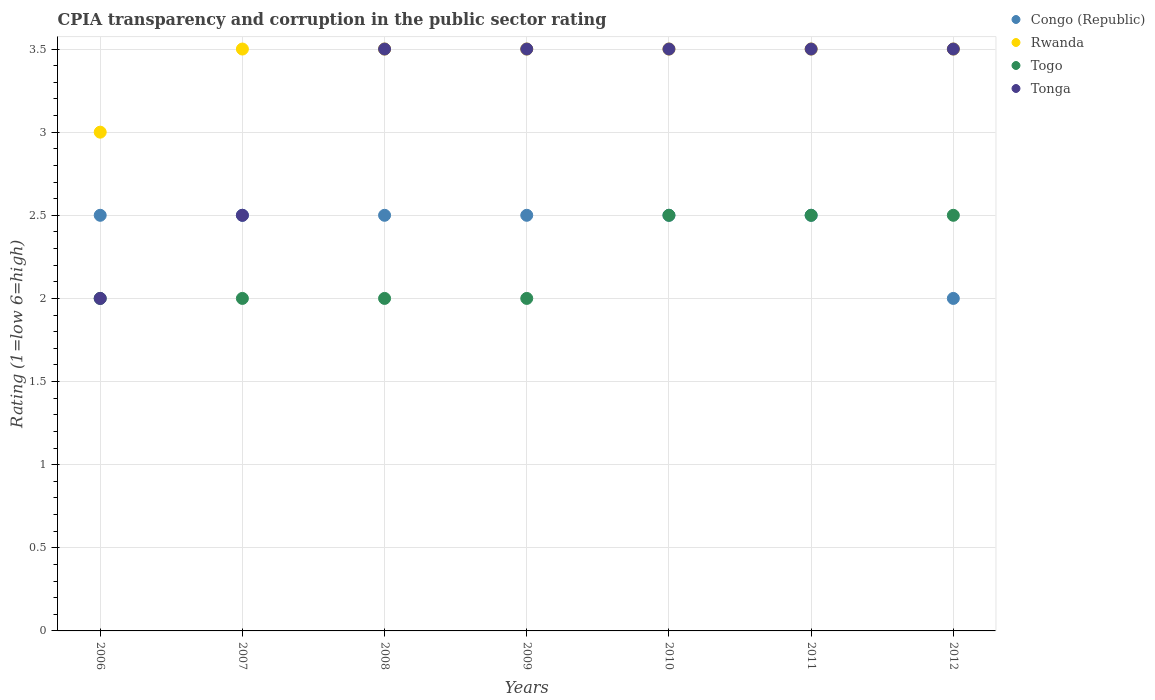How many different coloured dotlines are there?
Ensure brevity in your answer.  4. Across all years, what is the maximum CPIA rating in Congo (Republic)?
Your answer should be very brief. 2.5. Across all years, what is the minimum CPIA rating in Congo (Republic)?
Offer a terse response. 2. In which year was the CPIA rating in Tonga maximum?
Your answer should be very brief. 2008. What is the total CPIA rating in Tonga in the graph?
Your answer should be compact. 22. What is the difference between the CPIA rating in Togo in 2006 and that in 2010?
Your answer should be very brief. -0.5. What is the average CPIA rating in Congo (Republic) per year?
Make the answer very short. 2.43. In the year 2010, what is the difference between the CPIA rating in Rwanda and CPIA rating in Togo?
Offer a very short reply. 1. What is the ratio of the CPIA rating in Tonga in 2006 to that in 2008?
Your answer should be compact. 0.57. What is the difference between the highest and the lowest CPIA rating in Tonga?
Give a very brief answer. 1.5. In how many years, is the CPIA rating in Togo greater than the average CPIA rating in Togo taken over all years?
Offer a terse response. 3. Is the sum of the CPIA rating in Togo in 2007 and 2012 greater than the maximum CPIA rating in Congo (Republic) across all years?
Make the answer very short. Yes. Is it the case that in every year, the sum of the CPIA rating in Congo (Republic) and CPIA rating in Rwanda  is greater than the sum of CPIA rating in Tonga and CPIA rating in Togo?
Provide a succinct answer. Yes. Is it the case that in every year, the sum of the CPIA rating in Congo (Republic) and CPIA rating in Tonga  is greater than the CPIA rating in Rwanda?
Give a very brief answer. Yes. Does the CPIA rating in Togo monotonically increase over the years?
Your response must be concise. No. Is the CPIA rating in Tonga strictly greater than the CPIA rating in Rwanda over the years?
Your response must be concise. No. How many dotlines are there?
Make the answer very short. 4. Does the graph contain grids?
Your answer should be compact. Yes. How many legend labels are there?
Provide a short and direct response. 4. What is the title of the graph?
Your answer should be compact. CPIA transparency and corruption in the public sector rating. What is the label or title of the X-axis?
Ensure brevity in your answer.  Years. What is the Rating (1=low 6=high) of Congo (Republic) in 2006?
Make the answer very short. 2.5. What is the Rating (1=low 6=high) in Tonga in 2006?
Make the answer very short. 2. What is the Rating (1=low 6=high) of Congo (Republic) in 2007?
Make the answer very short. 2.5. What is the Rating (1=low 6=high) in Togo in 2007?
Provide a succinct answer. 2. What is the Rating (1=low 6=high) in Tonga in 2007?
Your response must be concise. 2.5. What is the Rating (1=low 6=high) in Rwanda in 2008?
Offer a terse response. 3.5. What is the Rating (1=low 6=high) in Togo in 2008?
Ensure brevity in your answer.  2. What is the Rating (1=low 6=high) of Togo in 2009?
Your answer should be very brief. 2. What is the Rating (1=low 6=high) in Congo (Republic) in 2010?
Give a very brief answer. 2.5. What is the Rating (1=low 6=high) of Togo in 2010?
Provide a succinct answer. 2.5. What is the Rating (1=low 6=high) in Tonga in 2010?
Your response must be concise. 3.5. What is the Rating (1=low 6=high) of Congo (Republic) in 2011?
Give a very brief answer. 2.5. What is the Rating (1=low 6=high) in Rwanda in 2011?
Give a very brief answer. 3.5. What is the Rating (1=low 6=high) in Congo (Republic) in 2012?
Make the answer very short. 2. What is the Rating (1=low 6=high) in Togo in 2012?
Make the answer very short. 2.5. What is the Rating (1=low 6=high) of Tonga in 2012?
Make the answer very short. 3.5. Across all years, what is the maximum Rating (1=low 6=high) in Tonga?
Ensure brevity in your answer.  3.5. Across all years, what is the minimum Rating (1=low 6=high) in Congo (Republic)?
Keep it short and to the point. 2. Across all years, what is the minimum Rating (1=low 6=high) in Tonga?
Keep it short and to the point. 2. What is the total Rating (1=low 6=high) of Rwanda in the graph?
Ensure brevity in your answer.  24. What is the total Rating (1=low 6=high) in Tonga in the graph?
Make the answer very short. 22. What is the difference between the Rating (1=low 6=high) in Congo (Republic) in 2006 and that in 2007?
Provide a short and direct response. 0. What is the difference between the Rating (1=low 6=high) of Togo in 2006 and that in 2007?
Provide a short and direct response. 0. What is the difference between the Rating (1=low 6=high) of Tonga in 2006 and that in 2007?
Make the answer very short. -0.5. What is the difference between the Rating (1=low 6=high) in Togo in 2006 and that in 2008?
Ensure brevity in your answer.  0. What is the difference between the Rating (1=low 6=high) of Togo in 2006 and that in 2009?
Offer a terse response. 0. What is the difference between the Rating (1=low 6=high) of Tonga in 2006 and that in 2009?
Provide a succinct answer. -1.5. What is the difference between the Rating (1=low 6=high) of Rwanda in 2006 and that in 2010?
Provide a short and direct response. -0.5. What is the difference between the Rating (1=low 6=high) in Togo in 2006 and that in 2010?
Your response must be concise. -0.5. What is the difference between the Rating (1=low 6=high) of Tonga in 2006 and that in 2010?
Offer a very short reply. -1.5. What is the difference between the Rating (1=low 6=high) of Congo (Republic) in 2006 and that in 2011?
Ensure brevity in your answer.  0. What is the difference between the Rating (1=low 6=high) of Togo in 2006 and that in 2011?
Your answer should be very brief. -0.5. What is the difference between the Rating (1=low 6=high) of Tonga in 2006 and that in 2011?
Offer a terse response. -1.5. What is the difference between the Rating (1=low 6=high) in Tonga in 2006 and that in 2012?
Your response must be concise. -1.5. What is the difference between the Rating (1=low 6=high) in Tonga in 2007 and that in 2008?
Your answer should be compact. -1. What is the difference between the Rating (1=low 6=high) in Congo (Republic) in 2007 and that in 2010?
Your answer should be compact. 0. What is the difference between the Rating (1=low 6=high) in Rwanda in 2007 and that in 2010?
Provide a short and direct response. 0. What is the difference between the Rating (1=low 6=high) in Togo in 2007 and that in 2010?
Offer a very short reply. -0.5. What is the difference between the Rating (1=low 6=high) of Togo in 2007 and that in 2011?
Provide a short and direct response. -0.5. What is the difference between the Rating (1=low 6=high) in Rwanda in 2007 and that in 2012?
Make the answer very short. 0. What is the difference between the Rating (1=low 6=high) in Togo in 2007 and that in 2012?
Your answer should be compact. -0.5. What is the difference between the Rating (1=low 6=high) in Togo in 2008 and that in 2009?
Your response must be concise. 0. What is the difference between the Rating (1=low 6=high) in Congo (Republic) in 2008 and that in 2010?
Your answer should be very brief. 0. What is the difference between the Rating (1=low 6=high) of Rwanda in 2008 and that in 2010?
Your response must be concise. 0. What is the difference between the Rating (1=low 6=high) in Tonga in 2008 and that in 2010?
Offer a terse response. 0. What is the difference between the Rating (1=low 6=high) in Rwanda in 2008 and that in 2011?
Provide a short and direct response. 0. What is the difference between the Rating (1=low 6=high) of Togo in 2008 and that in 2012?
Your response must be concise. -0.5. What is the difference between the Rating (1=low 6=high) in Tonga in 2008 and that in 2012?
Give a very brief answer. 0. What is the difference between the Rating (1=low 6=high) of Togo in 2009 and that in 2010?
Provide a short and direct response. -0.5. What is the difference between the Rating (1=low 6=high) in Tonga in 2009 and that in 2010?
Keep it short and to the point. 0. What is the difference between the Rating (1=low 6=high) of Togo in 2009 and that in 2011?
Offer a terse response. -0.5. What is the difference between the Rating (1=low 6=high) of Congo (Republic) in 2009 and that in 2012?
Offer a very short reply. 0.5. What is the difference between the Rating (1=low 6=high) of Rwanda in 2009 and that in 2012?
Provide a short and direct response. 0. What is the difference between the Rating (1=low 6=high) in Tonga in 2009 and that in 2012?
Provide a succinct answer. 0. What is the difference between the Rating (1=low 6=high) in Congo (Republic) in 2010 and that in 2011?
Give a very brief answer. 0. What is the difference between the Rating (1=low 6=high) in Rwanda in 2010 and that in 2011?
Make the answer very short. 0. What is the difference between the Rating (1=low 6=high) in Tonga in 2010 and that in 2011?
Keep it short and to the point. 0. What is the difference between the Rating (1=low 6=high) of Congo (Republic) in 2010 and that in 2012?
Your response must be concise. 0.5. What is the difference between the Rating (1=low 6=high) in Togo in 2010 and that in 2012?
Provide a short and direct response. 0. What is the difference between the Rating (1=low 6=high) in Tonga in 2010 and that in 2012?
Offer a very short reply. 0. What is the difference between the Rating (1=low 6=high) of Togo in 2011 and that in 2012?
Your response must be concise. 0. What is the difference between the Rating (1=low 6=high) in Congo (Republic) in 2006 and the Rating (1=low 6=high) in Rwanda in 2007?
Offer a terse response. -1. What is the difference between the Rating (1=low 6=high) in Rwanda in 2006 and the Rating (1=low 6=high) in Togo in 2007?
Make the answer very short. 1. What is the difference between the Rating (1=low 6=high) of Togo in 2006 and the Rating (1=low 6=high) of Tonga in 2007?
Offer a very short reply. -0.5. What is the difference between the Rating (1=low 6=high) in Congo (Republic) in 2006 and the Rating (1=low 6=high) in Rwanda in 2008?
Your response must be concise. -1. What is the difference between the Rating (1=low 6=high) of Rwanda in 2006 and the Rating (1=low 6=high) of Togo in 2008?
Your answer should be very brief. 1. What is the difference between the Rating (1=low 6=high) in Rwanda in 2006 and the Rating (1=low 6=high) in Tonga in 2008?
Give a very brief answer. -0.5. What is the difference between the Rating (1=low 6=high) of Congo (Republic) in 2006 and the Rating (1=low 6=high) of Togo in 2009?
Offer a terse response. 0.5. What is the difference between the Rating (1=low 6=high) of Congo (Republic) in 2006 and the Rating (1=low 6=high) of Tonga in 2009?
Your response must be concise. -1. What is the difference between the Rating (1=low 6=high) in Rwanda in 2006 and the Rating (1=low 6=high) in Togo in 2009?
Provide a short and direct response. 1. What is the difference between the Rating (1=low 6=high) in Rwanda in 2006 and the Rating (1=low 6=high) in Tonga in 2009?
Your answer should be very brief. -0.5. What is the difference between the Rating (1=low 6=high) in Togo in 2006 and the Rating (1=low 6=high) in Tonga in 2009?
Offer a terse response. -1.5. What is the difference between the Rating (1=low 6=high) of Congo (Republic) in 2006 and the Rating (1=low 6=high) of Rwanda in 2010?
Provide a short and direct response. -1. What is the difference between the Rating (1=low 6=high) of Congo (Republic) in 2006 and the Rating (1=low 6=high) of Togo in 2010?
Offer a very short reply. 0. What is the difference between the Rating (1=low 6=high) of Congo (Republic) in 2006 and the Rating (1=low 6=high) of Tonga in 2010?
Make the answer very short. -1. What is the difference between the Rating (1=low 6=high) in Rwanda in 2006 and the Rating (1=low 6=high) in Togo in 2010?
Make the answer very short. 0.5. What is the difference between the Rating (1=low 6=high) of Rwanda in 2006 and the Rating (1=low 6=high) of Tonga in 2010?
Offer a terse response. -0.5. What is the difference between the Rating (1=low 6=high) of Congo (Republic) in 2006 and the Rating (1=low 6=high) of Rwanda in 2011?
Your response must be concise. -1. What is the difference between the Rating (1=low 6=high) in Rwanda in 2006 and the Rating (1=low 6=high) in Togo in 2011?
Offer a very short reply. 0.5. What is the difference between the Rating (1=low 6=high) in Rwanda in 2006 and the Rating (1=low 6=high) in Tonga in 2011?
Keep it short and to the point. -0.5. What is the difference between the Rating (1=low 6=high) of Congo (Republic) in 2006 and the Rating (1=low 6=high) of Rwanda in 2012?
Keep it short and to the point. -1. What is the difference between the Rating (1=low 6=high) of Congo (Republic) in 2006 and the Rating (1=low 6=high) of Togo in 2012?
Your answer should be compact. 0. What is the difference between the Rating (1=low 6=high) in Congo (Republic) in 2006 and the Rating (1=low 6=high) in Tonga in 2012?
Ensure brevity in your answer.  -1. What is the difference between the Rating (1=low 6=high) of Togo in 2006 and the Rating (1=low 6=high) of Tonga in 2012?
Ensure brevity in your answer.  -1.5. What is the difference between the Rating (1=low 6=high) in Congo (Republic) in 2007 and the Rating (1=low 6=high) in Togo in 2008?
Keep it short and to the point. 0.5. What is the difference between the Rating (1=low 6=high) in Rwanda in 2007 and the Rating (1=low 6=high) in Tonga in 2008?
Offer a terse response. 0. What is the difference between the Rating (1=low 6=high) in Rwanda in 2007 and the Rating (1=low 6=high) in Togo in 2009?
Give a very brief answer. 1.5. What is the difference between the Rating (1=low 6=high) of Togo in 2007 and the Rating (1=low 6=high) of Tonga in 2009?
Ensure brevity in your answer.  -1.5. What is the difference between the Rating (1=low 6=high) of Rwanda in 2007 and the Rating (1=low 6=high) of Tonga in 2010?
Make the answer very short. 0. What is the difference between the Rating (1=low 6=high) in Togo in 2007 and the Rating (1=low 6=high) in Tonga in 2010?
Offer a very short reply. -1.5. What is the difference between the Rating (1=low 6=high) of Congo (Republic) in 2007 and the Rating (1=low 6=high) of Tonga in 2011?
Your answer should be compact. -1. What is the difference between the Rating (1=low 6=high) of Rwanda in 2007 and the Rating (1=low 6=high) of Tonga in 2011?
Make the answer very short. 0. What is the difference between the Rating (1=low 6=high) of Togo in 2007 and the Rating (1=low 6=high) of Tonga in 2011?
Ensure brevity in your answer.  -1.5. What is the difference between the Rating (1=low 6=high) of Togo in 2007 and the Rating (1=low 6=high) of Tonga in 2012?
Your answer should be very brief. -1.5. What is the difference between the Rating (1=low 6=high) in Congo (Republic) in 2008 and the Rating (1=low 6=high) in Togo in 2009?
Provide a short and direct response. 0.5. What is the difference between the Rating (1=low 6=high) in Congo (Republic) in 2008 and the Rating (1=low 6=high) in Tonga in 2009?
Your answer should be compact. -1. What is the difference between the Rating (1=low 6=high) of Togo in 2008 and the Rating (1=low 6=high) of Tonga in 2009?
Offer a very short reply. -1.5. What is the difference between the Rating (1=low 6=high) in Congo (Republic) in 2008 and the Rating (1=low 6=high) in Togo in 2010?
Provide a short and direct response. 0. What is the difference between the Rating (1=low 6=high) in Congo (Republic) in 2008 and the Rating (1=low 6=high) in Tonga in 2010?
Provide a short and direct response. -1. What is the difference between the Rating (1=low 6=high) in Congo (Republic) in 2008 and the Rating (1=low 6=high) in Rwanda in 2011?
Your response must be concise. -1. What is the difference between the Rating (1=low 6=high) of Togo in 2008 and the Rating (1=low 6=high) of Tonga in 2011?
Provide a succinct answer. -1.5. What is the difference between the Rating (1=low 6=high) of Congo (Republic) in 2008 and the Rating (1=low 6=high) of Tonga in 2012?
Make the answer very short. -1. What is the difference between the Rating (1=low 6=high) of Rwanda in 2008 and the Rating (1=low 6=high) of Togo in 2012?
Provide a short and direct response. 1. What is the difference between the Rating (1=low 6=high) of Rwanda in 2008 and the Rating (1=low 6=high) of Tonga in 2012?
Ensure brevity in your answer.  0. What is the difference between the Rating (1=low 6=high) of Congo (Republic) in 2009 and the Rating (1=low 6=high) of Togo in 2010?
Provide a succinct answer. 0. What is the difference between the Rating (1=low 6=high) of Congo (Republic) in 2009 and the Rating (1=low 6=high) of Togo in 2011?
Offer a terse response. 0. What is the difference between the Rating (1=low 6=high) in Togo in 2009 and the Rating (1=low 6=high) in Tonga in 2011?
Offer a very short reply. -1.5. What is the difference between the Rating (1=low 6=high) in Congo (Republic) in 2009 and the Rating (1=low 6=high) in Rwanda in 2012?
Offer a terse response. -1. What is the difference between the Rating (1=low 6=high) of Congo (Republic) in 2009 and the Rating (1=low 6=high) of Tonga in 2012?
Keep it short and to the point. -1. What is the difference between the Rating (1=low 6=high) in Rwanda in 2009 and the Rating (1=low 6=high) in Togo in 2012?
Ensure brevity in your answer.  1. What is the difference between the Rating (1=low 6=high) in Rwanda in 2009 and the Rating (1=low 6=high) in Tonga in 2012?
Provide a succinct answer. 0. What is the difference between the Rating (1=low 6=high) of Togo in 2009 and the Rating (1=low 6=high) of Tonga in 2012?
Make the answer very short. -1.5. What is the difference between the Rating (1=low 6=high) of Congo (Republic) in 2010 and the Rating (1=low 6=high) of Togo in 2011?
Make the answer very short. 0. What is the difference between the Rating (1=low 6=high) of Congo (Republic) in 2010 and the Rating (1=low 6=high) of Tonga in 2011?
Keep it short and to the point. -1. What is the difference between the Rating (1=low 6=high) of Rwanda in 2010 and the Rating (1=low 6=high) of Togo in 2011?
Offer a very short reply. 1. What is the difference between the Rating (1=low 6=high) in Congo (Republic) in 2010 and the Rating (1=low 6=high) in Togo in 2012?
Provide a succinct answer. 0. What is the difference between the Rating (1=low 6=high) in Rwanda in 2010 and the Rating (1=low 6=high) in Togo in 2012?
Your response must be concise. 1. What is the difference between the Rating (1=low 6=high) of Rwanda in 2010 and the Rating (1=low 6=high) of Tonga in 2012?
Your answer should be compact. 0. What is the difference between the Rating (1=low 6=high) of Congo (Republic) in 2011 and the Rating (1=low 6=high) of Rwanda in 2012?
Your answer should be very brief. -1. What is the difference between the Rating (1=low 6=high) in Congo (Republic) in 2011 and the Rating (1=low 6=high) in Togo in 2012?
Offer a terse response. 0. What is the difference between the Rating (1=low 6=high) in Rwanda in 2011 and the Rating (1=low 6=high) in Togo in 2012?
Provide a succinct answer. 1. What is the difference between the Rating (1=low 6=high) in Togo in 2011 and the Rating (1=low 6=high) in Tonga in 2012?
Your response must be concise. -1. What is the average Rating (1=low 6=high) of Congo (Republic) per year?
Your answer should be very brief. 2.43. What is the average Rating (1=low 6=high) in Rwanda per year?
Ensure brevity in your answer.  3.43. What is the average Rating (1=low 6=high) in Togo per year?
Keep it short and to the point. 2.21. What is the average Rating (1=low 6=high) in Tonga per year?
Your answer should be very brief. 3.14. In the year 2006, what is the difference between the Rating (1=low 6=high) of Congo (Republic) and Rating (1=low 6=high) of Tonga?
Your answer should be compact. 0.5. In the year 2006, what is the difference between the Rating (1=low 6=high) in Rwanda and Rating (1=low 6=high) in Tonga?
Offer a very short reply. 1. In the year 2006, what is the difference between the Rating (1=low 6=high) in Togo and Rating (1=low 6=high) in Tonga?
Offer a terse response. 0. In the year 2007, what is the difference between the Rating (1=low 6=high) of Congo (Republic) and Rating (1=low 6=high) of Rwanda?
Your response must be concise. -1. In the year 2007, what is the difference between the Rating (1=low 6=high) in Congo (Republic) and Rating (1=low 6=high) in Togo?
Your response must be concise. 0.5. In the year 2007, what is the difference between the Rating (1=low 6=high) in Congo (Republic) and Rating (1=low 6=high) in Tonga?
Make the answer very short. 0. In the year 2007, what is the difference between the Rating (1=low 6=high) in Rwanda and Rating (1=low 6=high) in Togo?
Your response must be concise. 1.5. In the year 2008, what is the difference between the Rating (1=low 6=high) in Congo (Republic) and Rating (1=low 6=high) in Tonga?
Your answer should be compact. -1. In the year 2008, what is the difference between the Rating (1=low 6=high) of Rwanda and Rating (1=low 6=high) of Tonga?
Your response must be concise. 0. In the year 2009, what is the difference between the Rating (1=low 6=high) of Congo (Republic) and Rating (1=low 6=high) of Togo?
Offer a terse response. 0.5. In the year 2009, what is the difference between the Rating (1=low 6=high) of Rwanda and Rating (1=low 6=high) of Tonga?
Offer a terse response. 0. In the year 2009, what is the difference between the Rating (1=low 6=high) in Togo and Rating (1=low 6=high) in Tonga?
Offer a very short reply. -1.5. In the year 2010, what is the difference between the Rating (1=low 6=high) of Congo (Republic) and Rating (1=low 6=high) of Togo?
Offer a very short reply. 0. In the year 2010, what is the difference between the Rating (1=low 6=high) in Congo (Republic) and Rating (1=low 6=high) in Tonga?
Your answer should be compact. -1. In the year 2010, what is the difference between the Rating (1=low 6=high) in Rwanda and Rating (1=low 6=high) in Togo?
Your answer should be compact. 1. In the year 2010, what is the difference between the Rating (1=low 6=high) of Togo and Rating (1=low 6=high) of Tonga?
Provide a short and direct response. -1. In the year 2011, what is the difference between the Rating (1=low 6=high) in Congo (Republic) and Rating (1=low 6=high) in Togo?
Provide a short and direct response. 0. In the year 2011, what is the difference between the Rating (1=low 6=high) of Rwanda and Rating (1=low 6=high) of Togo?
Provide a succinct answer. 1. In the year 2011, what is the difference between the Rating (1=low 6=high) in Togo and Rating (1=low 6=high) in Tonga?
Your answer should be compact. -1. In the year 2012, what is the difference between the Rating (1=low 6=high) in Congo (Republic) and Rating (1=low 6=high) in Tonga?
Your response must be concise. -1.5. In the year 2012, what is the difference between the Rating (1=low 6=high) in Togo and Rating (1=low 6=high) in Tonga?
Offer a very short reply. -1. What is the ratio of the Rating (1=low 6=high) of Congo (Republic) in 2006 to that in 2007?
Make the answer very short. 1. What is the ratio of the Rating (1=low 6=high) in Rwanda in 2006 to that in 2007?
Your answer should be very brief. 0.86. What is the ratio of the Rating (1=low 6=high) of Congo (Republic) in 2006 to that in 2008?
Your answer should be compact. 1. What is the ratio of the Rating (1=low 6=high) of Togo in 2006 to that in 2008?
Give a very brief answer. 1. What is the ratio of the Rating (1=low 6=high) in Tonga in 2006 to that in 2008?
Your response must be concise. 0.57. What is the ratio of the Rating (1=low 6=high) of Congo (Republic) in 2006 to that in 2009?
Offer a terse response. 1. What is the ratio of the Rating (1=low 6=high) of Rwanda in 2006 to that in 2009?
Give a very brief answer. 0.86. What is the ratio of the Rating (1=low 6=high) in Togo in 2006 to that in 2009?
Provide a short and direct response. 1. What is the ratio of the Rating (1=low 6=high) in Congo (Republic) in 2006 to that in 2010?
Offer a terse response. 1. What is the ratio of the Rating (1=low 6=high) of Togo in 2006 to that in 2010?
Ensure brevity in your answer.  0.8. What is the ratio of the Rating (1=low 6=high) of Tonga in 2006 to that in 2010?
Give a very brief answer. 0.57. What is the ratio of the Rating (1=low 6=high) of Congo (Republic) in 2006 to that in 2011?
Offer a very short reply. 1. What is the ratio of the Rating (1=low 6=high) of Togo in 2006 to that in 2011?
Provide a short and direct response. 0.8. What is the ratio of the Rating (1=low 6=high) of Tonga in 2006 to that in 2011?
Make the answer very short. 0.57. What is the ratio of the Rating (1=low 6=high) in Congo (Republic) in 2006 to that in 2012?
Your answer should be compact. 1.25. What is the ratio of the Rating (1=low 6=high) of Tonga in 2006 to that in 2012?
Ensure brevity in your answer.  0.57. What is the ratio of the Rating (1=low 6=high) of Rwanda in 2007 to that in 2008?
Your response must be concise. 1. What is the ratio of the Rating (1=low 6=high) in Togo in 2007 to that in 2008?
Make the answer very short. 1. What is the ratio of the Rating (1=low 6=high) of Congo (Republic) in 2007 to that in 2009?
Provide a short and direct response. 1. What is the ratio of the Rating (1=low 6=high) of Rwanda in 2007 to that in 2009?
Offer a very short reply. 1. What is the ratio of the Rating (1=low 6=high) of Tonga in 2007 to that in 2009?
Ensure brevity in your answer.  0.71. What is the ratio of the Rating (1=low 6=high) of Togo in 2007 to that in 2010?
Ensure brevity in your answer.  0.8. What is the ratio of the Rating (1=low 6=high) of Tonga in 2007 to that in 2010?
Provide a short and direct response. 0.71. What is the ratio of the Rating (1=low 6=high) of Congo (Republic) in 2007 to that in 2011?
Ensure brevity in your answer.  1. What is the ratio of the Rating (1=low 6=high) in Tonga in 2007 to that in 2011?
Ensure brevity in your answer.  0.71. What is the ratio of the Rating (1=low 6=high) of Togo in 2007 to that in 2012?
Give a very brief answer. 0.8. What is the ratio of the Rating (1=low 6=high) in Tonga in 2007 to that in 2012?
Offer a very short reply. 0.71. What is the ratio of the Rating (1=low 6=high) in Congo (Republic) in 2008 to that in 2009?
Keep it short and to the point. 1. What is the ratio of the Rating (1=low 6=high) in Rwanda in 2008 to that in 2009?
Give a very brief answer. 1. What is the ratio of the Rating (1=low 6=high) of Togo in 2008 to that in 2009?
Your response must be concise. 1. What is the ratio of the Rating (1=low 6=high) in Tonga in 2008 to that in 2009?
Your response must be concise. 1. What is the ratio of the Rating (1=low 6=high) of Congo (Republic) in 2008 to that in 2010?
Offer a terse response. 1. What is the ratio of the Rating (1=low 6=high) in Congo (Republic) in 2008 to that in 2011?
Offer a very short reply. 1. What is the ratio of the Rating (1=low 6=high) in Rwanda in 2008 to that in 2011?
Ensure brevity in your answer.  1. What is the ratio of the Rating (1=low 6=high) of Togo in 2008 to that in 2011?
Your answer should be very brief. 0.8. What is the ratio of the Rating (1=low 6=high) in Tonga in 2008 to that in 2011?
Give a very brief answer. 1. What is the ratio of the Rating (1=low 6=high) in Tonga in 2008 to that in 2012?
Make the answer very short. 1. What is the ratio of the Rating (1=low 6=high) in Rwanda in 2009 to that in 2010?
Your answer should be compact. 1. What is the ratio of the Rating (1=low 6=high) in Togo in 2009 to that in 2011?
Keep it short and to the point. 0.8. What is the ratio of the Rating (1=low 6=high) of Congo (Republic) in 2009 to that in 2012?
Provide a succinct answer. 1.25. What is the ratio of the Rating (1=low 6=high) in Tonga in 2009 to that in 2012?
Provide a short and direct response. 1. What is the ratio of the Rating (1=low 6=high) of Congo (Republic) in 2010 to that in 2011?
Give a very brief answer. 1. What is the ratio of the Rating (1=low 6=high) of Tonga in 2010 to that in 2011?
Keep it short and to the point. 1. What is the ratio of the Rating (1=low 6=high) of Togo in 2010 to that in 2012?
Offer a very short reply. 1. What is the ratio of the Rating (1=low 6=high) of Rwanda in 2011 to that in 2012?
Provide a short and direct response. 1. What is the difference between the highest and the lowest Rating (1=low 6=high) of Tonga?
Ensure brevity in your answer.  1.5. 